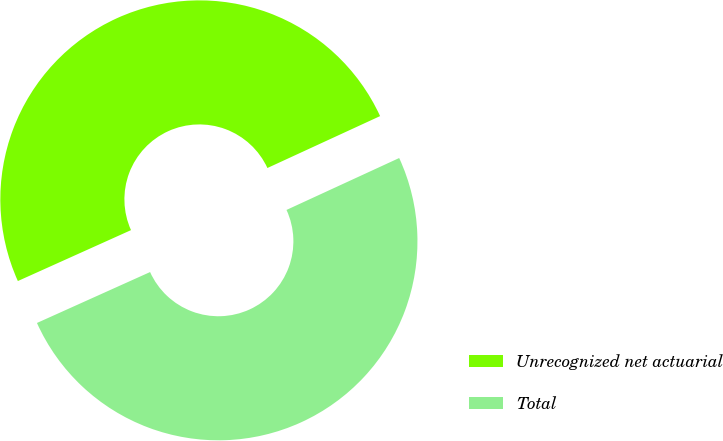Convert chart. <chart><loc_0><loc_0><loc_500><loc_500><pie_chart><fcel>Unrecognized net actuarial<fcel>Total<nl><fcel>49.86%<fcel>50.14%<nl></chart> 